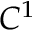Convert formula to latex. <formula><loc_0><loc_0><loc_500><loc_500>C ^ { 1 }</formula> 